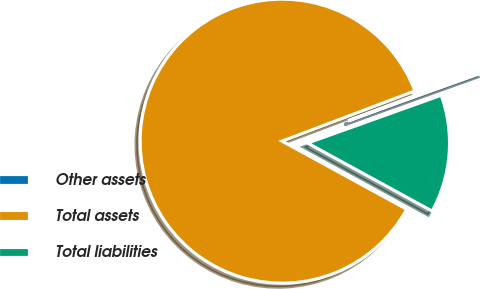Convert chart to OTSL. <chart><loc_0><loc_0><loc_500><loc_500><pie_chart><fcel>Other assets<fcel>Total assets<fcel>Total liabilities<nl><fcel>0.28%<fcel>86.29%<fcel>13.43%<nl></chart> 